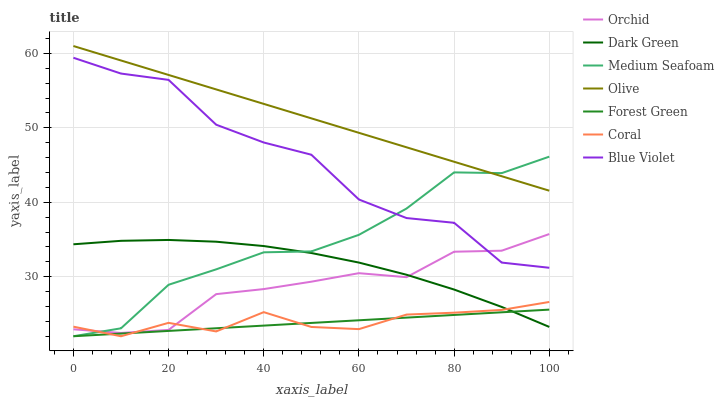Does Forest Green have the minimum area under the curve?
Answer yes or no. Yes. Does Olive have the maximum area under the curve?
Answer yes or no. Yes. Does Olive have the minimum area under the curve?
Answer yes or no. No. Does Forest Green have the maximum area under the curve?
Answer yes or no. No. Is Forest Green the smoothest?
Answer yes or no. Yes. Is Blue Violet the roughest?
Answer yes or no. Yes. Is Orchid the smoothest?
Answer yes or no. No. Is Orchid the roughest?
Answer yes or no. No. Does Coral have the lowest value?
Answer yes or no. Yes. Does Olive have the lowest value?
Answer yes or no. No. Does Olive have the highest value?
Answer yes or no. Yes. Does Forest Green have the highest value?
Answer yes or no. No. Is Blue Violet less than Olive?
Answer yes or no. Yes. Is Blue Violet greater than Dark Green?
Answer yes or no. Yes. Does Orchid intersect Blue Violet?
Answer yes or no. Yes. Is Orchid less than Blue Violet?
Answer yes or no. No. Is Orchid greater than Blue Violet?
Answer yes or no. No. Does Blue Violet intersect Olive?
Answer yes or no. No. 